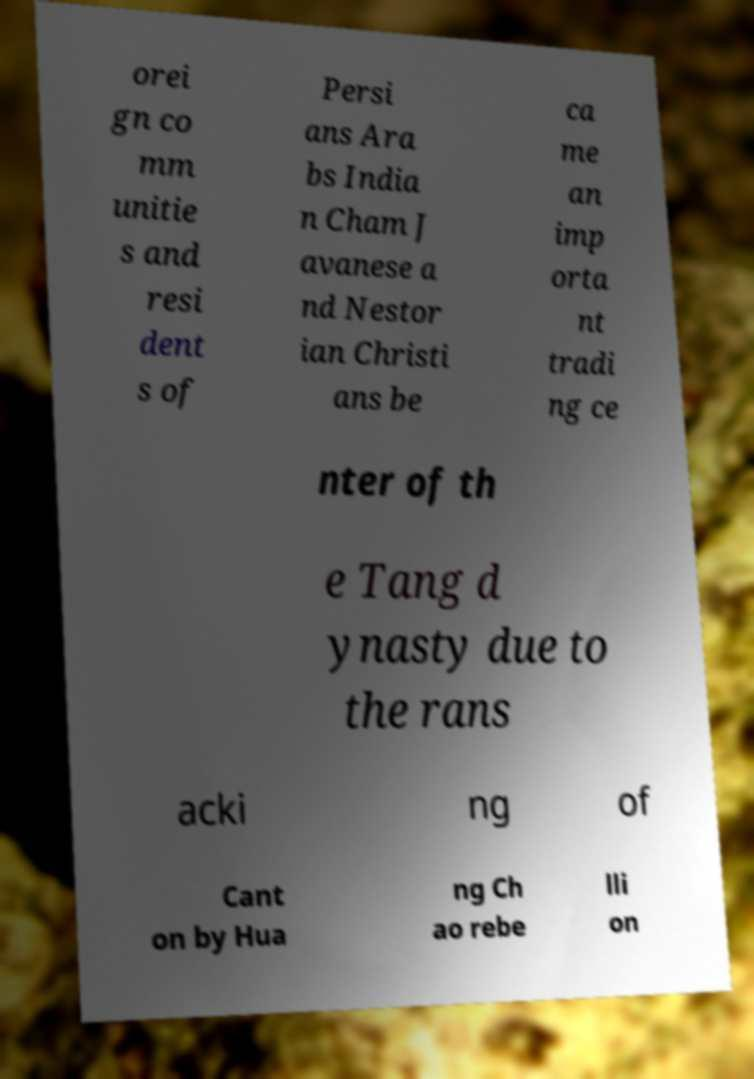What messages or text are displayed in this image? I need them in a readable, typed format. orei gn co mm unitie s and resi dent s of Persi ans Ara bs India n Cham J avanese a nd Nestor ian Christi ans be ca me an imp orta nt tradi ng ce nter of th e Tang d ynasty due to the rans acki ng of Cant on by Hua ng Ch ao rebe lli on 